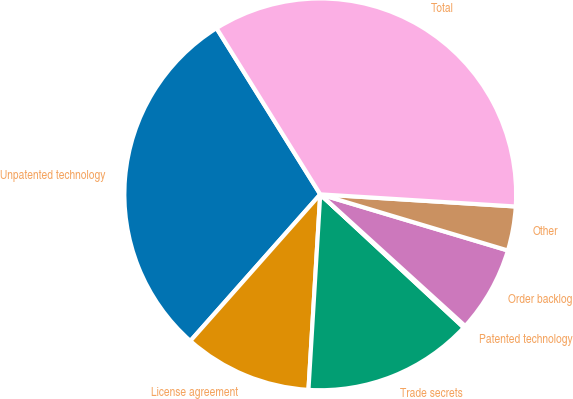Convert chart. <chart><loc_0><loc_0><loc_500><loc_500><pie_chart><fcel>Unpatented technology<fcel>License agreement<fcel>Trade secrets<fcel>Patented technology<fcel>Order backlog<fcel>Other<fcel>Total<nl><fcel>29.58%<fcel>10.58%<fcel>14.05%<fcel>0.17%<fcel>7.11%<fcel>3.64%<fcel>34.87%<nl></chart> 